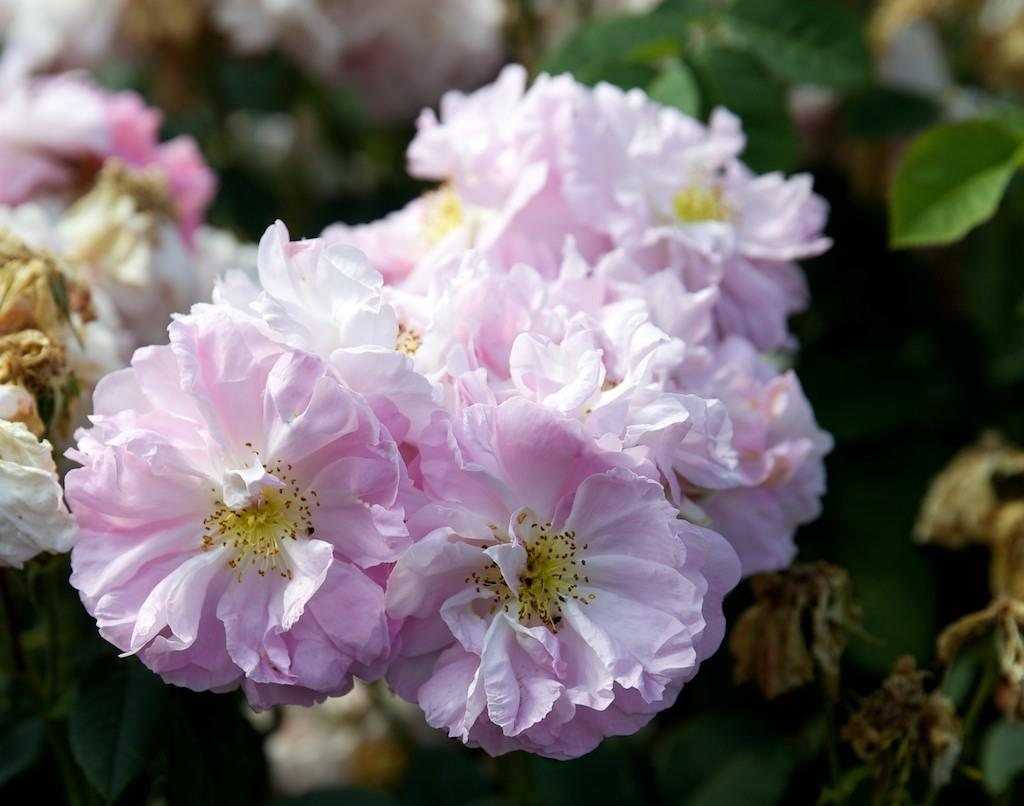What type of living organisms can be seen in the image? Plants can be seen in the image. Can you describe the flowers on the plants? Yes, there are pink color flowers on the plants in the image. How many goldfish are swimming in the drain in the image? There are no goldfish or drains present in the image; it features plants with pink flowers. 